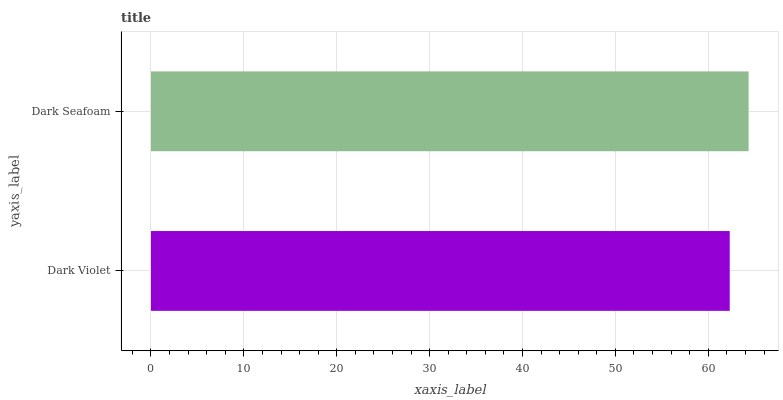Is Dark Violet the minimum?
Answer yes or no. Yes. Is Dark Seafoam the maximum?
Answer yes or no. Yes. Is Dark Seafoam the minimum?
Answer yes or no. No. Is Dark Seafoam greater than Dark Violet?
Answer yes or no. Yes. Is Dark Violet less than Dark Seafoam?
Answer yes or no. Yes. Is Dark Violet greater than Dark Seafoam?
Answer yes or no. No. Is Dark Seafoam less than Dark Violet?
Answer yes or no. No. Is Dark Seafoam the high median?
Answer yes or no. Yes. Is Dark Violet the low median?
Answer yes or no. Yes. Is Dark Violet the high median?
Answer yes or no. No. Is Dark Seafoam the low median?
Answer yes or no. No. 